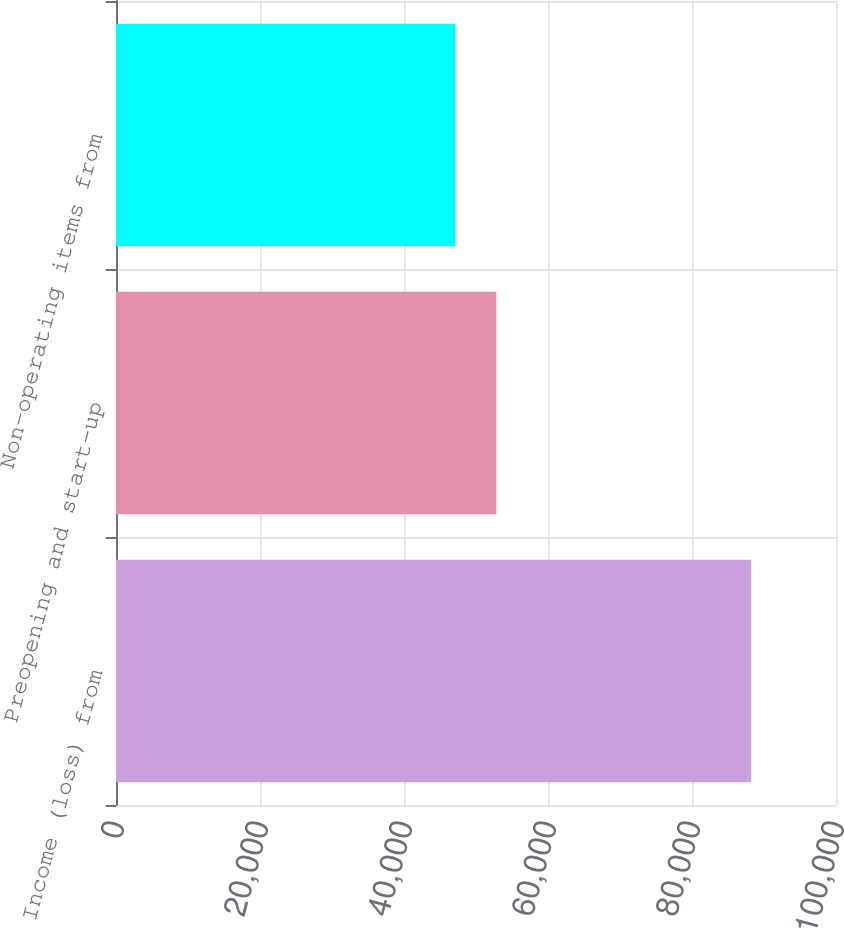<chart> <loc_0><loc_0><loc_500><loc_500><bar_chart><fcel>Income (loss) from<fcel>Preopening and start-up<fcel>Non-operating items from<nl><fcel>88227<fcel>52824<fcel>47127<nl></chart> 